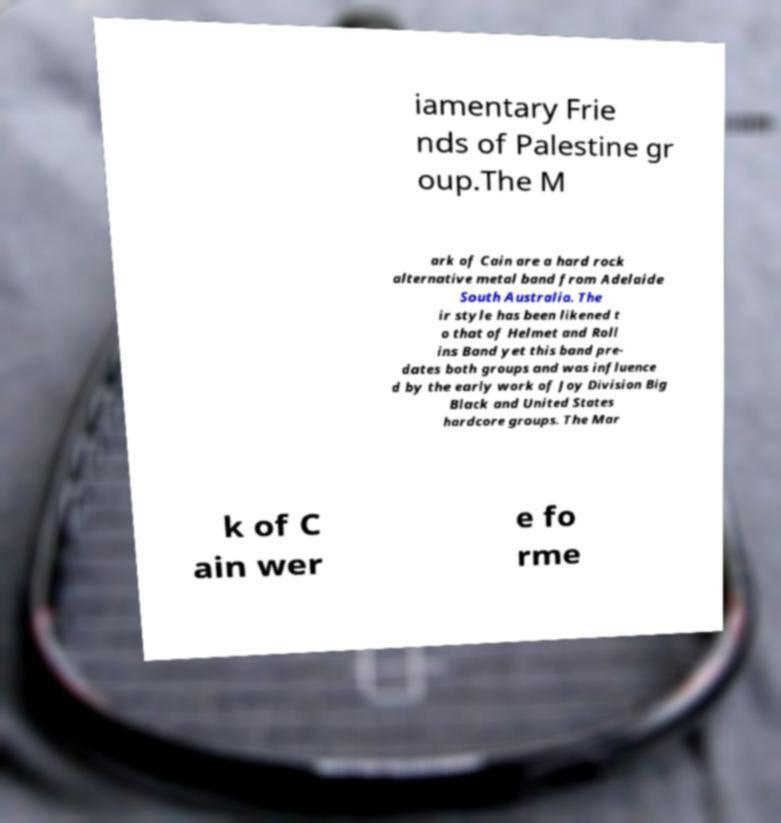Could you extract and type out the text from this image? iamentary Frie nds of Palestine gr oup.The M ark of Cain are a hard rock alternative metal band from Adelaide South Australia. The ir style has been likened t o that of Helmet and Roll ins Band yet this band pre- dates both groups and was influence d by the early work of Joy Division Big Black and United States hardcore groups. The Mar k of C ain wer e fo rme 